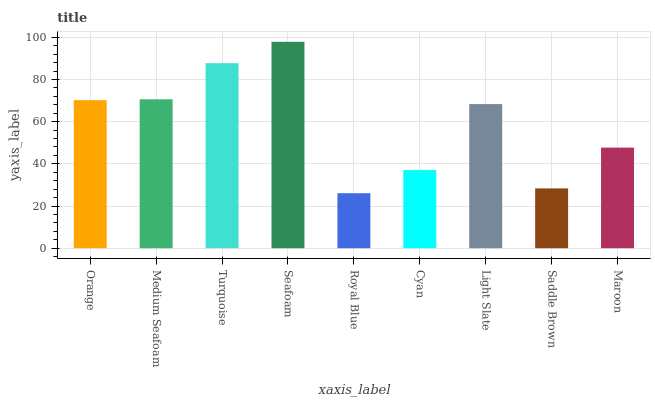Is Royal Blue the minimum?
Answer yes or no. Yes. Is Seafoam the maximum?
Answer yes or no. Yes. Is Medium Seafoam the minimum?
Answer yes or no. No. Is Medium Seafoam the maximum?
Answer yes or no. No. Is Medium Seafoam greater than Orange?
Answer yes or no. Yes. Is Orange less than Medium Seafoam?
Answer yes or no. Yes. Is Orange greater than Medium Seafoam?
Answer yes or no. No. Is Medium Seafoam less than Orange?
Answer yes or no. No. Is Light Slate the high median?
Answer yes or no. Yes. Is Light Slate the low median?
Answer yes or no. Yes. Is Royal Blue the high median?
Answer yes or no. No. Is Maroon the low median?
Answer yes or no. No. 